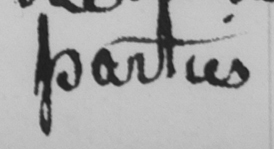Please provide the text content of this handwritten line. parties 